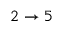Convert formula to latex. <formula><loc_0><loc_0><loc_500><loc_500>2 \to 5</formula> 